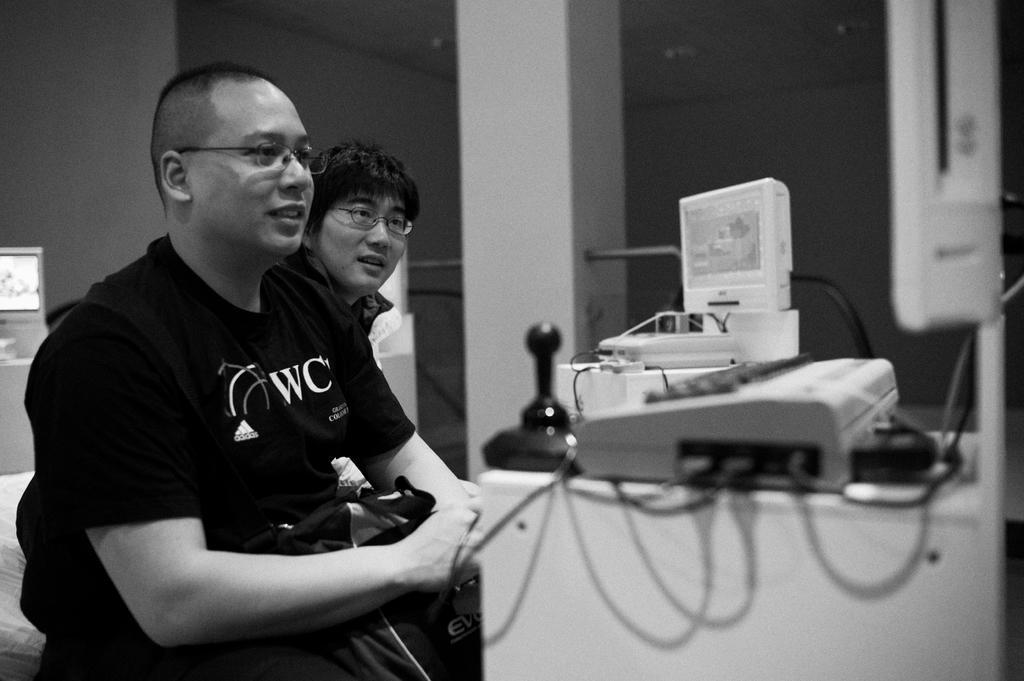Could you give a brief overview of what you see in this image? This is black and white image where we can see two persons are sitting. They both are wearing specs. In front of them one table is there. On the table some machines are there. Behind one pillars is there. 